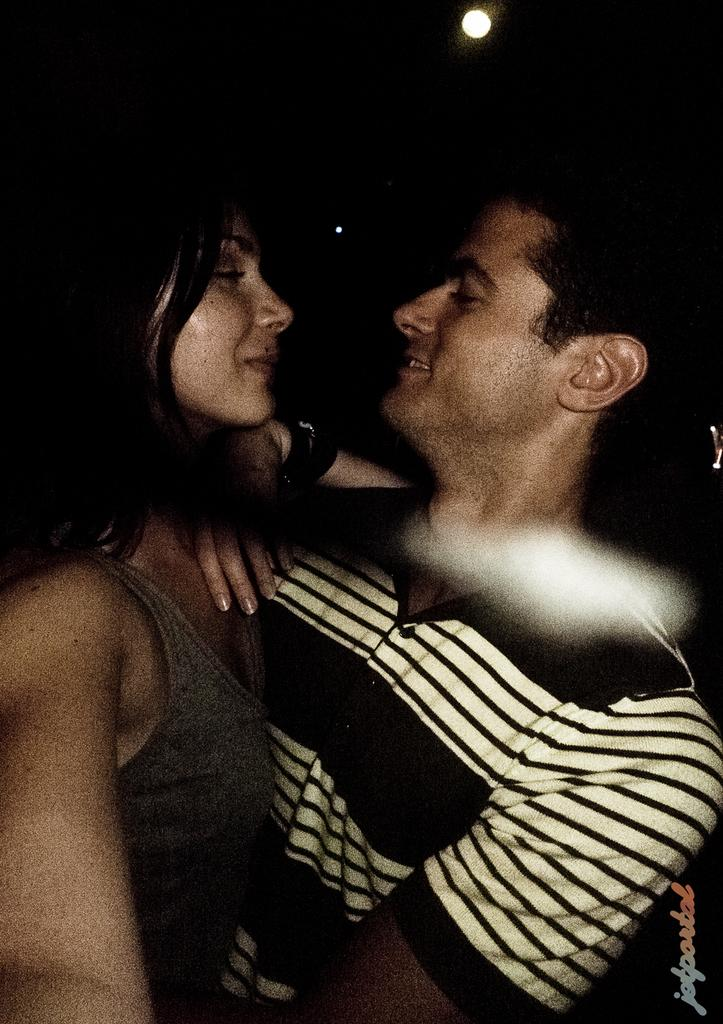How many people are present in the image? There is a man and a woman in the image. What is the color of the background in the image? The background of the image is dark. Can you describe the lighting in the image? There is light visible at the top of the image. What type of horse can be seen in the image? There is no horse present in the image. What is the woman doing with the apple in the image? There is no apple or any indication of the woman performing an action with an apple in the image. 